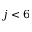Convert formula to latex. <formula><loc_0><loc_0><loc_500><loc_500>j < 6</formula> 